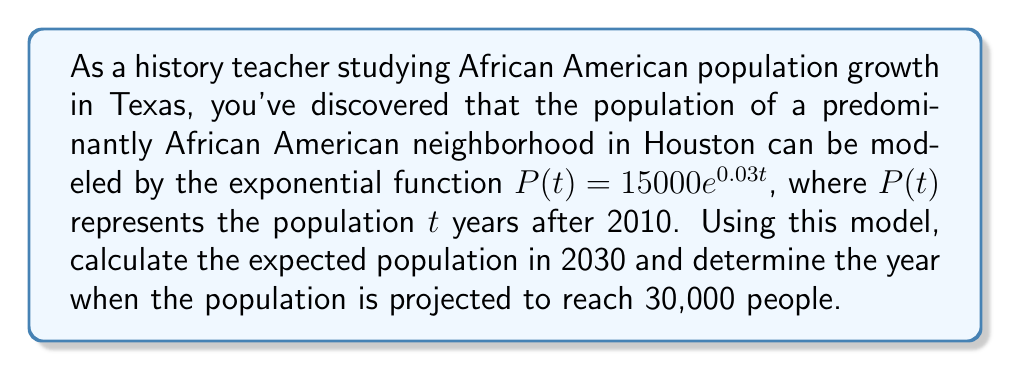Solve this math problem. To solve this problem, we'll use the given exponential function and apply it to the specific scenarios:

1. Finding the population in 2030:
   - The year 2030 is 20 years after 2010
   - Substitute $t = 20$ into the equation:
     $$P(20) = 15000e^{0.03(20)}$$
     $$P(20) = 15000e^{0.6}$$
     $$P(20) = 15000 \cdot 1.8221 \approx 27,331$$

2. Determining when the population reaches 30,000:
   - Set up the equation:
     $$30000 = 15000e^{0.03t}$$
   - Divide both sides by 15000:
     $$2 = e^{0.03t}$$
   - Take the natural log of both sides:
     $$\ln(2) = 0.03t$$
   - Solve for $t$:
     $$t = \frac{\ln(2)}{0.03} \approx 23.10$$

   Since $t$ represents years after 2010, add 23.10 to 2010:
   2010 + 23.10 = 2033.10

Therefore, the population is projected to reach 30,000 in early 2033.
Answer: The expected population in 2030 is approximately 27,331 people, and the population is projected to reach 30,000 people in early 2033. 